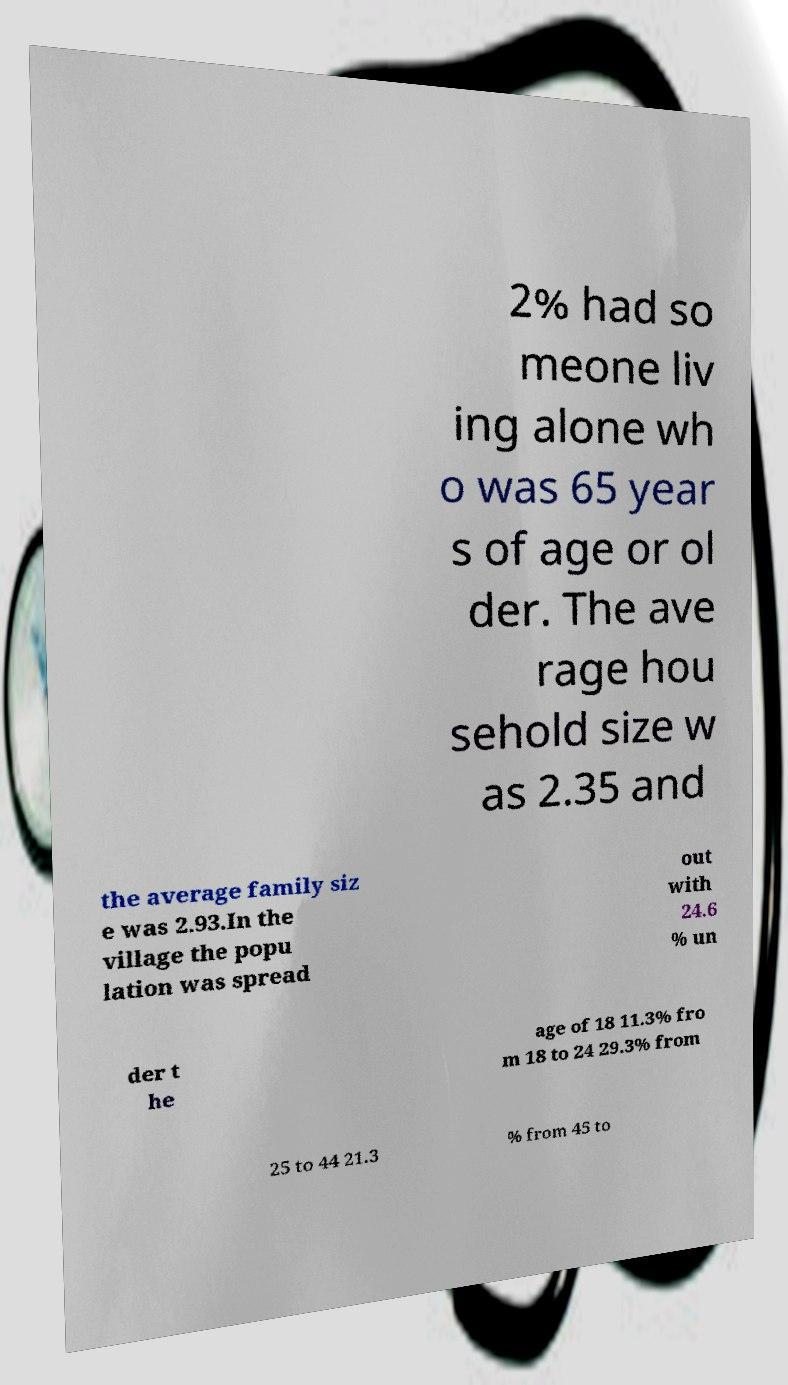Can you read and provide the text displayed in the image?This photo seems to have some interesting text. Can you extract and type it out for me? 2% had so meone liv ing alone wh o was 65 year s of age or ol der. The ave rage hou sehold size w as 2.35 and the average family siz e was 2.93.In the village the popu lation was spread out with 24.6 % un der t he age of 18 11.3% fro m 18 to 24 29.3% from 25 to 44 21.3 % from 45 to 